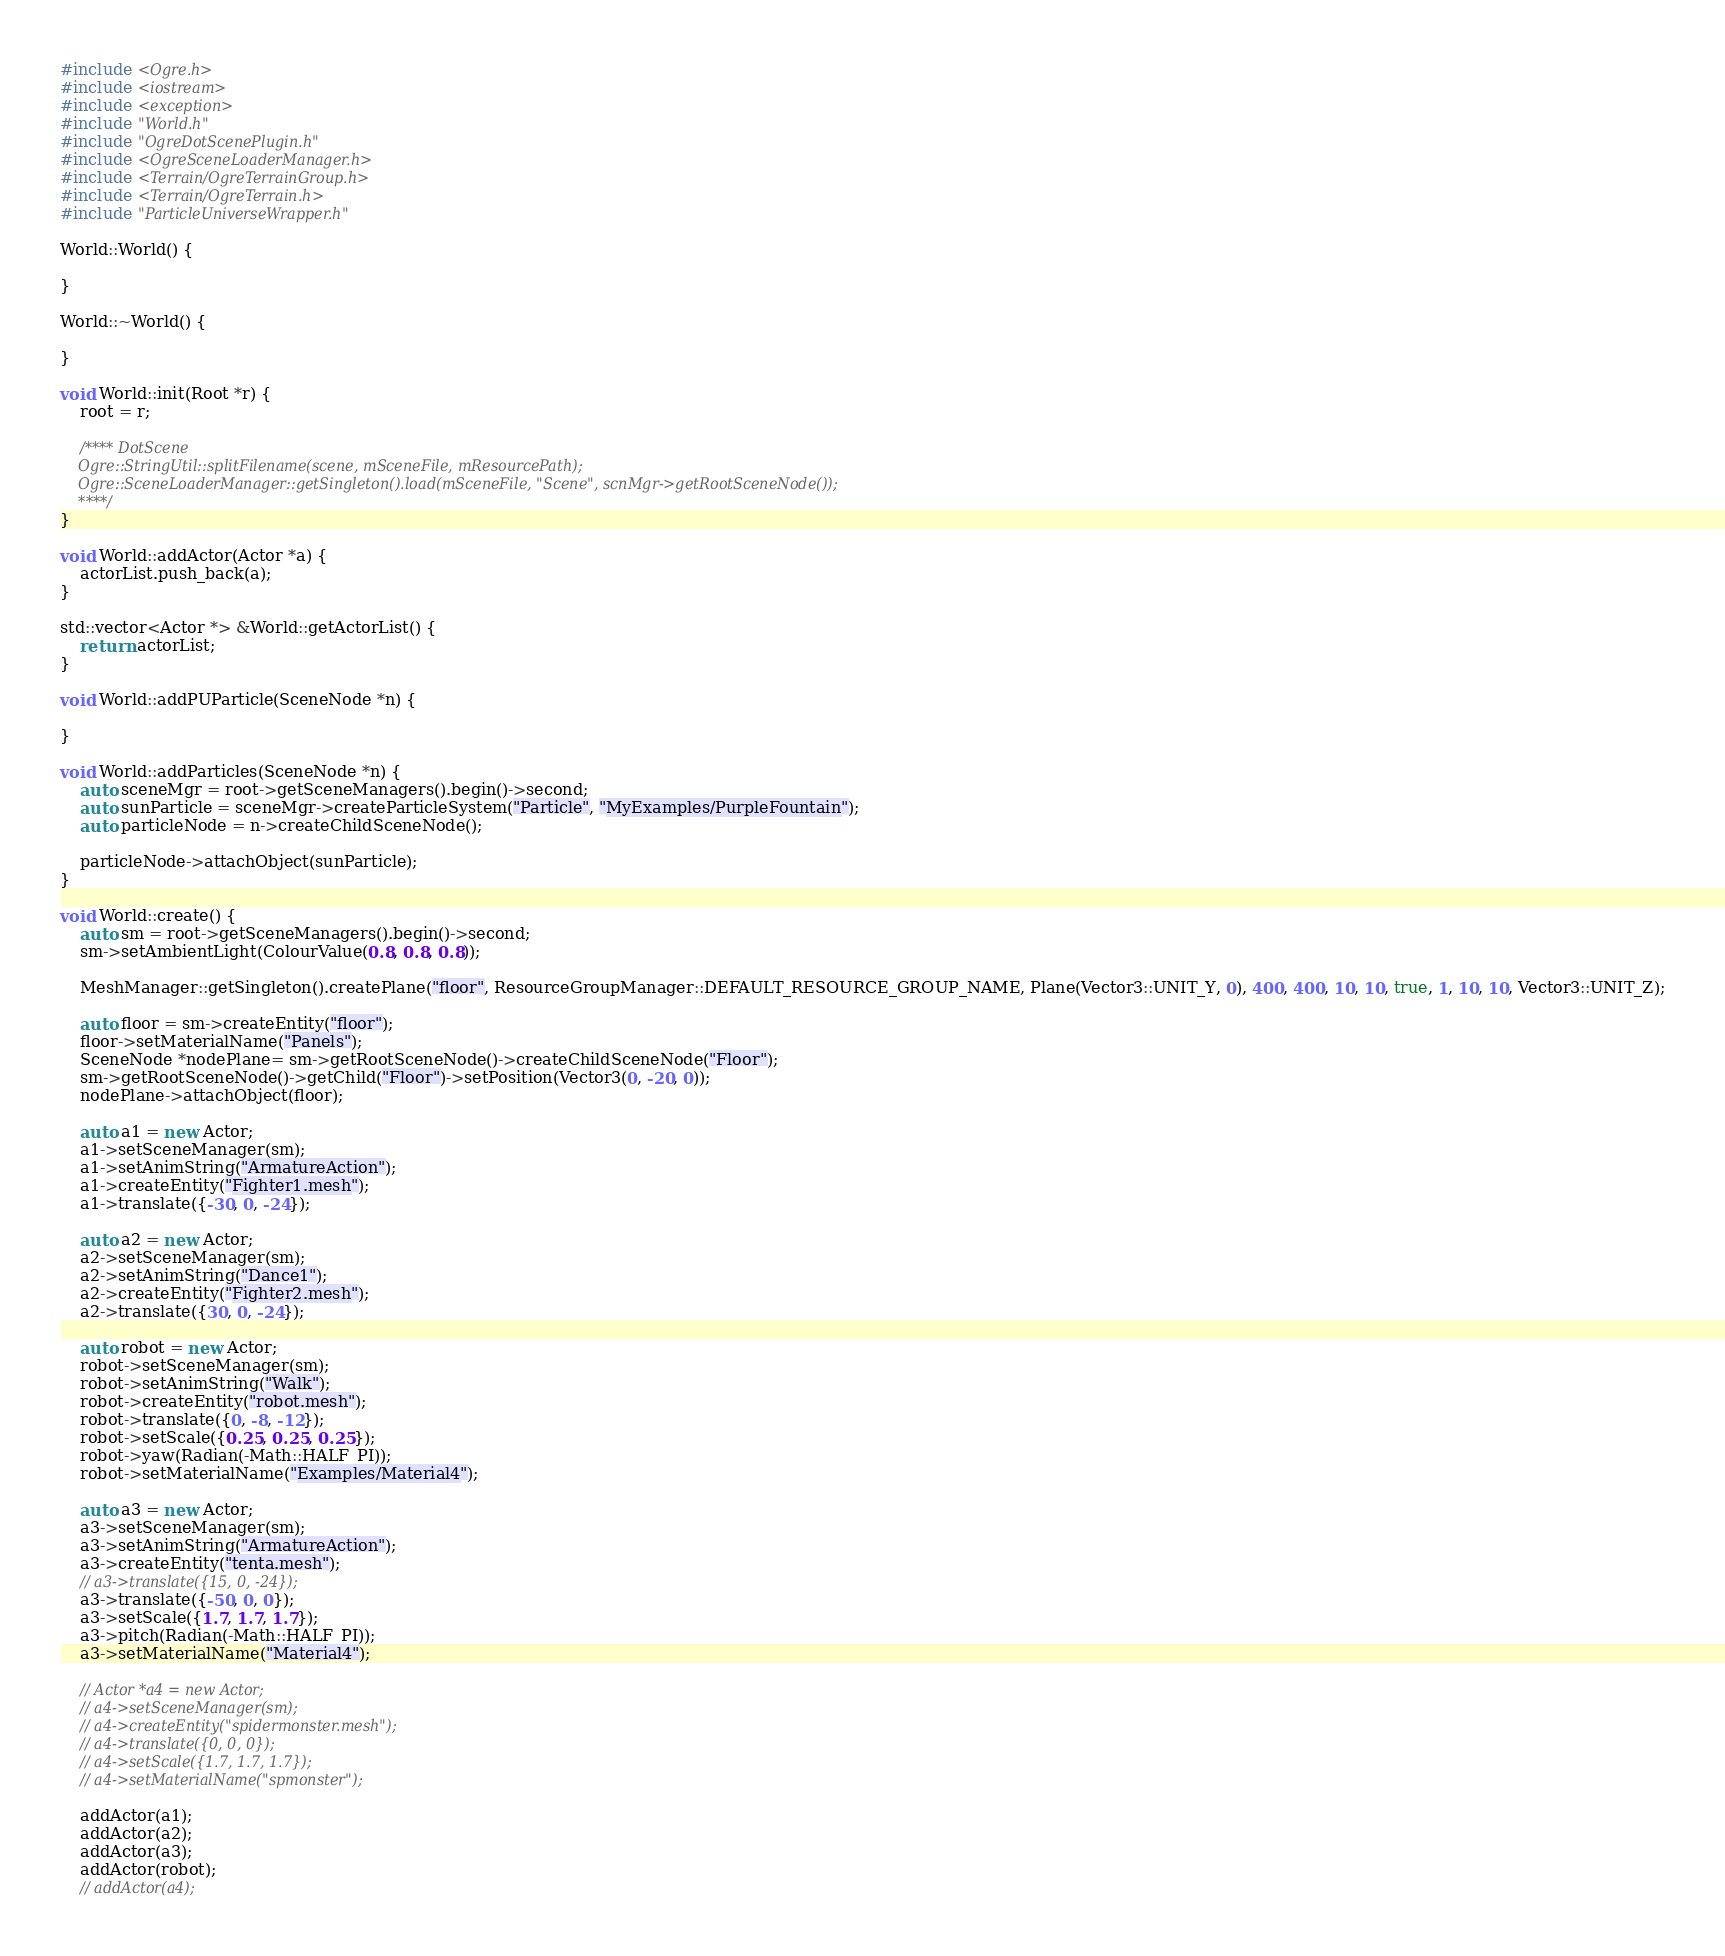<code> <loc_0><loc_0><loc_500><loc_500><_C++_>#include <Ogre.h>
#include <iostream>
#include <exception>
#include "World.h"
#include "OgreDotScenePlugin.h"
#include <OgreSceneLoaderManager.h>
#include <Terrain/OgreTerrainGroup.h>
#include <Terrain/OgreTerrain.h>
#include "ParticleUniverseWrapper.h"

World::World() {

}

World::~World() {

}

void World::init(Root *r) {
    root = r;

    /**** DotScene
    Ogre::StringUtil::splitFilename(scene, mSceneFile, mResourcePath);
    Ogre::SceneLoaderManager::getSingleton().load(mSceneFile, "Scene", scnMgr->getRootSceneNode());
    ****/
}

void World::addActor(Actor *a) {
    actorList.push_back(a);
}

std::vector<Actor *> &World::getActorList() {
    return actorList;
}

void World::addPUParticle(SceneNode *n) {

}

void World::addParticles(SceneNode *n) {
    auto sceneMgr = root->getSceneManagers().begin()->second;
    auto sunParticle = sceneMgr->createParticleSystem("Particle", "MyExamples/PurpleFountain");
    auto particleNode = n->createChildSceneNode();

    particleNode->attachObject(sunParticle);
}

void World::create() {
    auto sm = root->getSceneManagers().begin()->second;
    sm->setAmbientLight(ColourValue(0.8, 0.8, 0.8));

    MeshManager::getSingleton().createPlane("floor", ResourceGroupManager::DEFAULT_RESOURCE_GROUP_NAME, Plane(Vector3::UNIT_Y, 0), 400, 400, 10, 10, true, 1, 10, 10, Vector3::UNIT_Z);

    auto floor = sm->createEntity("floor");
    floor->setMaterialName("Panels");
    SceneNode *nodePlane= sm->getRootSceneNode()->createChildSceneNode("Floor");
    sm->getRootSceneNode()->getChild("Floor")->setPosition(Vector3(0, -20, 0));
    nodePlane->attachObject(floor);
    
    auto a1 = new Actor;
    a1->setSceneManager(sm);
    a1->setAnimString("ArmatureAction");
    a1->createEntity("Fighter1.mesh");
    a1->translate({-30, 0, -24});

    auto a2 = new Actor;
    a2->setSceneManager(sm);
    a2->setAnimString("Dance1");
    a2->createEntity("Fighter2.mesh");
    a2->translate({30, 0, -24});

    auto robot = new Actor;
    robot->setSceneManager(sm);
    robot->setAnimString("Walk");
    robot->createEntity("robot.mesh");
    robot->translate({0, -8, -12});
    robot->setScale({0.25, 0.25, 0.25});
    robot->yaw(Radian(-Math::HALF_PI));
    robot->setMaterialName("Examples/Material4");

    auto a3 = new Actor;
    a3->setSceneManager(sm);
    a3->setAnimString("ArmatureAction");
    a3->createEntity("tenta.mesh");
    // a3->translate({15, 0, -24});
    a3->translate({-50, 0, 0});
    a3->setScale({1.7, 1.7, 1.7});
    a3->pitch(Radian(-Math::HALF_PI));
    a3->setMaterialName("Material4");

    // Actor *a4 = new Actor;
    // a4->setSceneManager(sm);
    // a4->createEntity("spidermonster.mesh");
    // a4->translate({0, 0, 0});
    // a4->setScale({1.7, 1.7, 1.7});
    // a4->setMaterialName("spmonster");

    addActor(a1);
    addActor(a2);
    addActor(a3);
    addActor(robot);
    // addActor(a4);</code> 